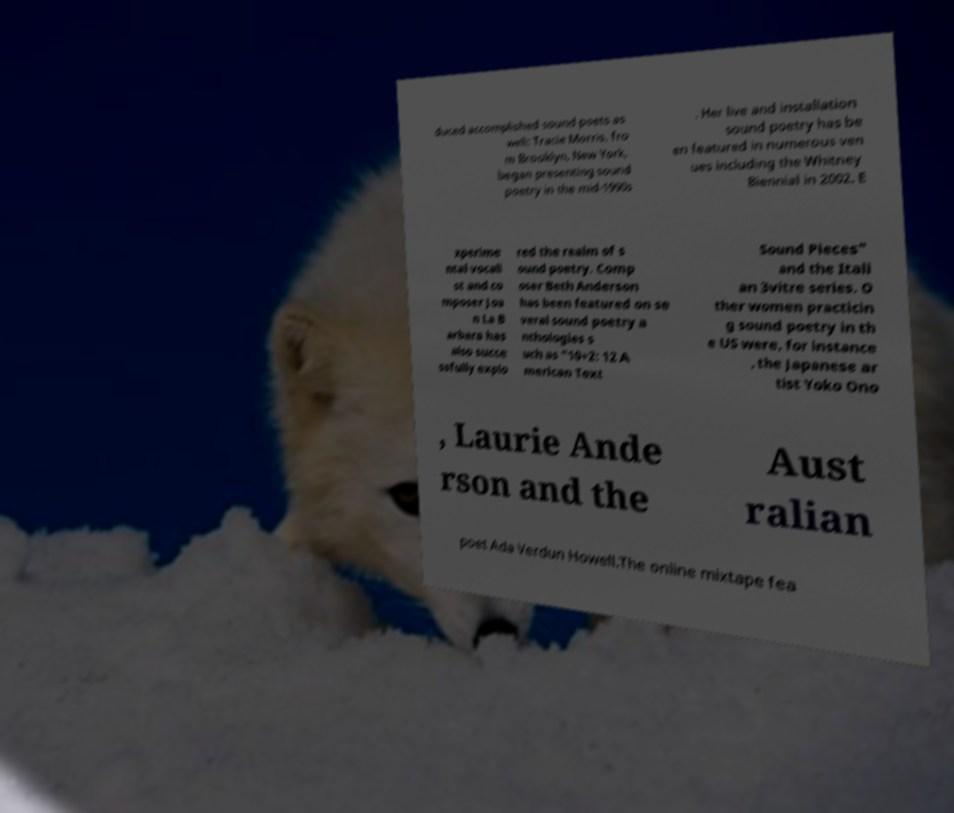Can you read and provide the text displayed in the image?This photo seems to have some interesting text. Can you extract and type it out for me? duced accomplished sound poets as well: Tracie Morris, fro m Brooklyn, New York, began presenting sound poetry in the mid-1990s . Her live and installation sound poetry has be en featured in numerous ven ues including the Whitney Biennial in 2002. E xperime ntal vocali st and co mposer Joa n La B arbara has also succe ssfully explo red the realm of s ound poetry. Comp oser Beth Anderson has been featured on se veral sound poetry a nthologies s uch as "10+2: 12 A merican Text Sound Pieces" and the Itali an 3vitre series. O ther women practicin g sound poetry in th e US were, for instance , the Japanese ar tist Yoko Ono , Laurie Ande rson and the Aust ralian poet Ada Verdun Howell.The online mixtape fea 